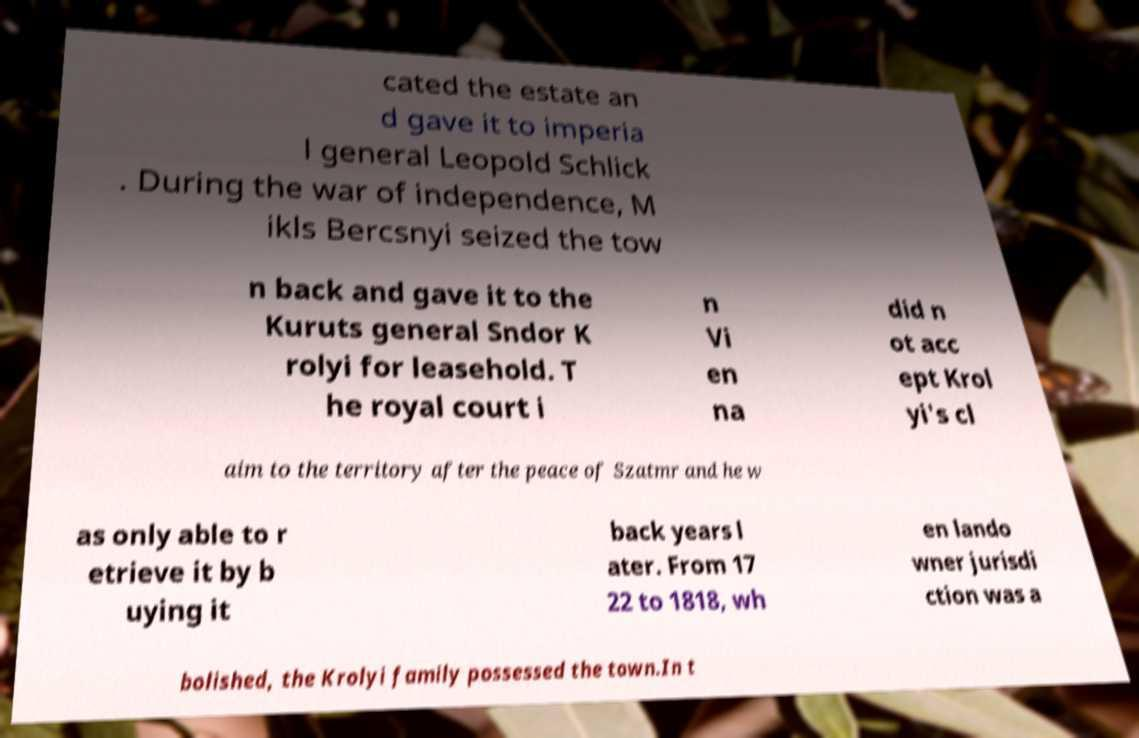For documentation purposes, I need the text within this image transcribed. Could you provide that? cated the estate an d gave it to imperia l general Leopold Schlick . During the war of independence, M ikls Bercsnyi seized the tow n back and gave it to the Kuruts general Sndor K rolyi for leasehold. T he royal court i n Vi en na did n ot acc ept Krol yi's cl aim to the territory after the peace of Szatmr and he w as only able to r etrieve it by b uying it back years l ater. From 17 22 to 1818, wh en lando wner jurisdi ction was a bolished, the Krolyi family possessed the town.In t 